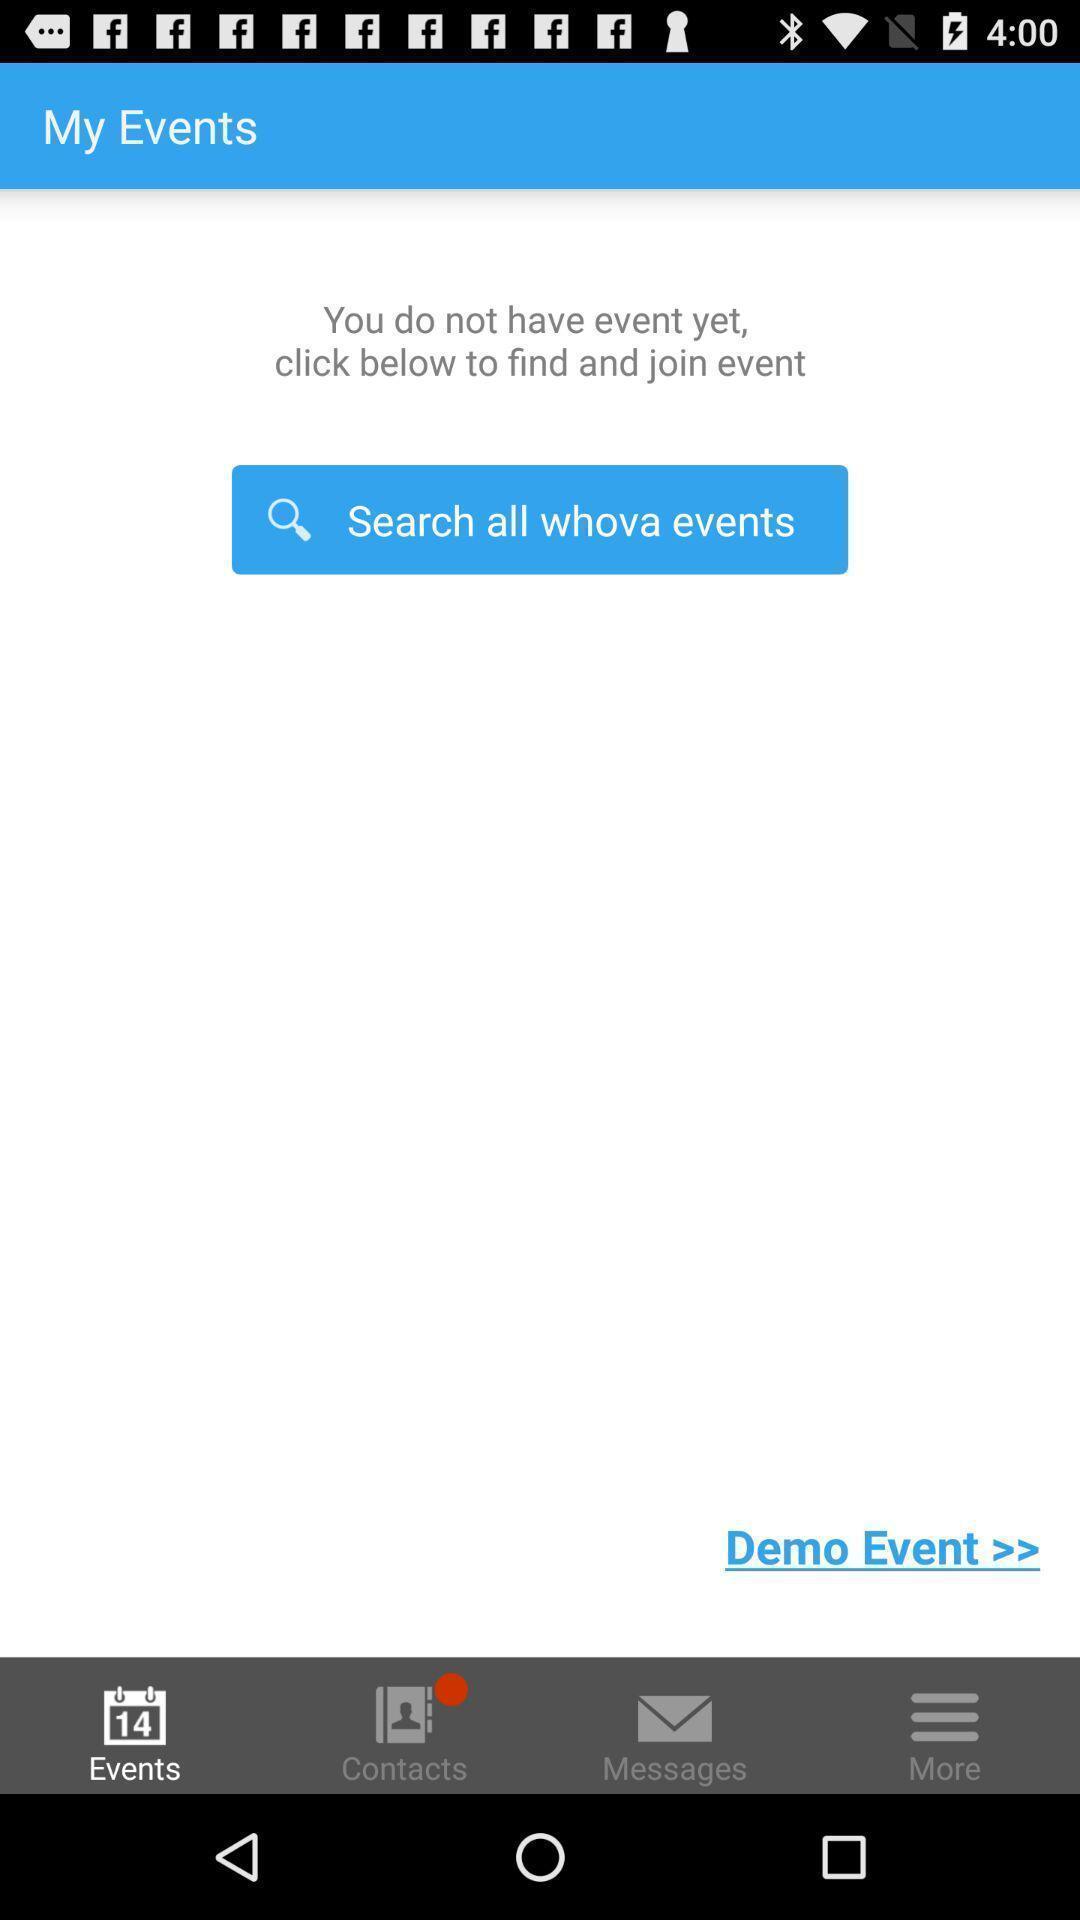What can you discern from this picture? Screen shows my events. 